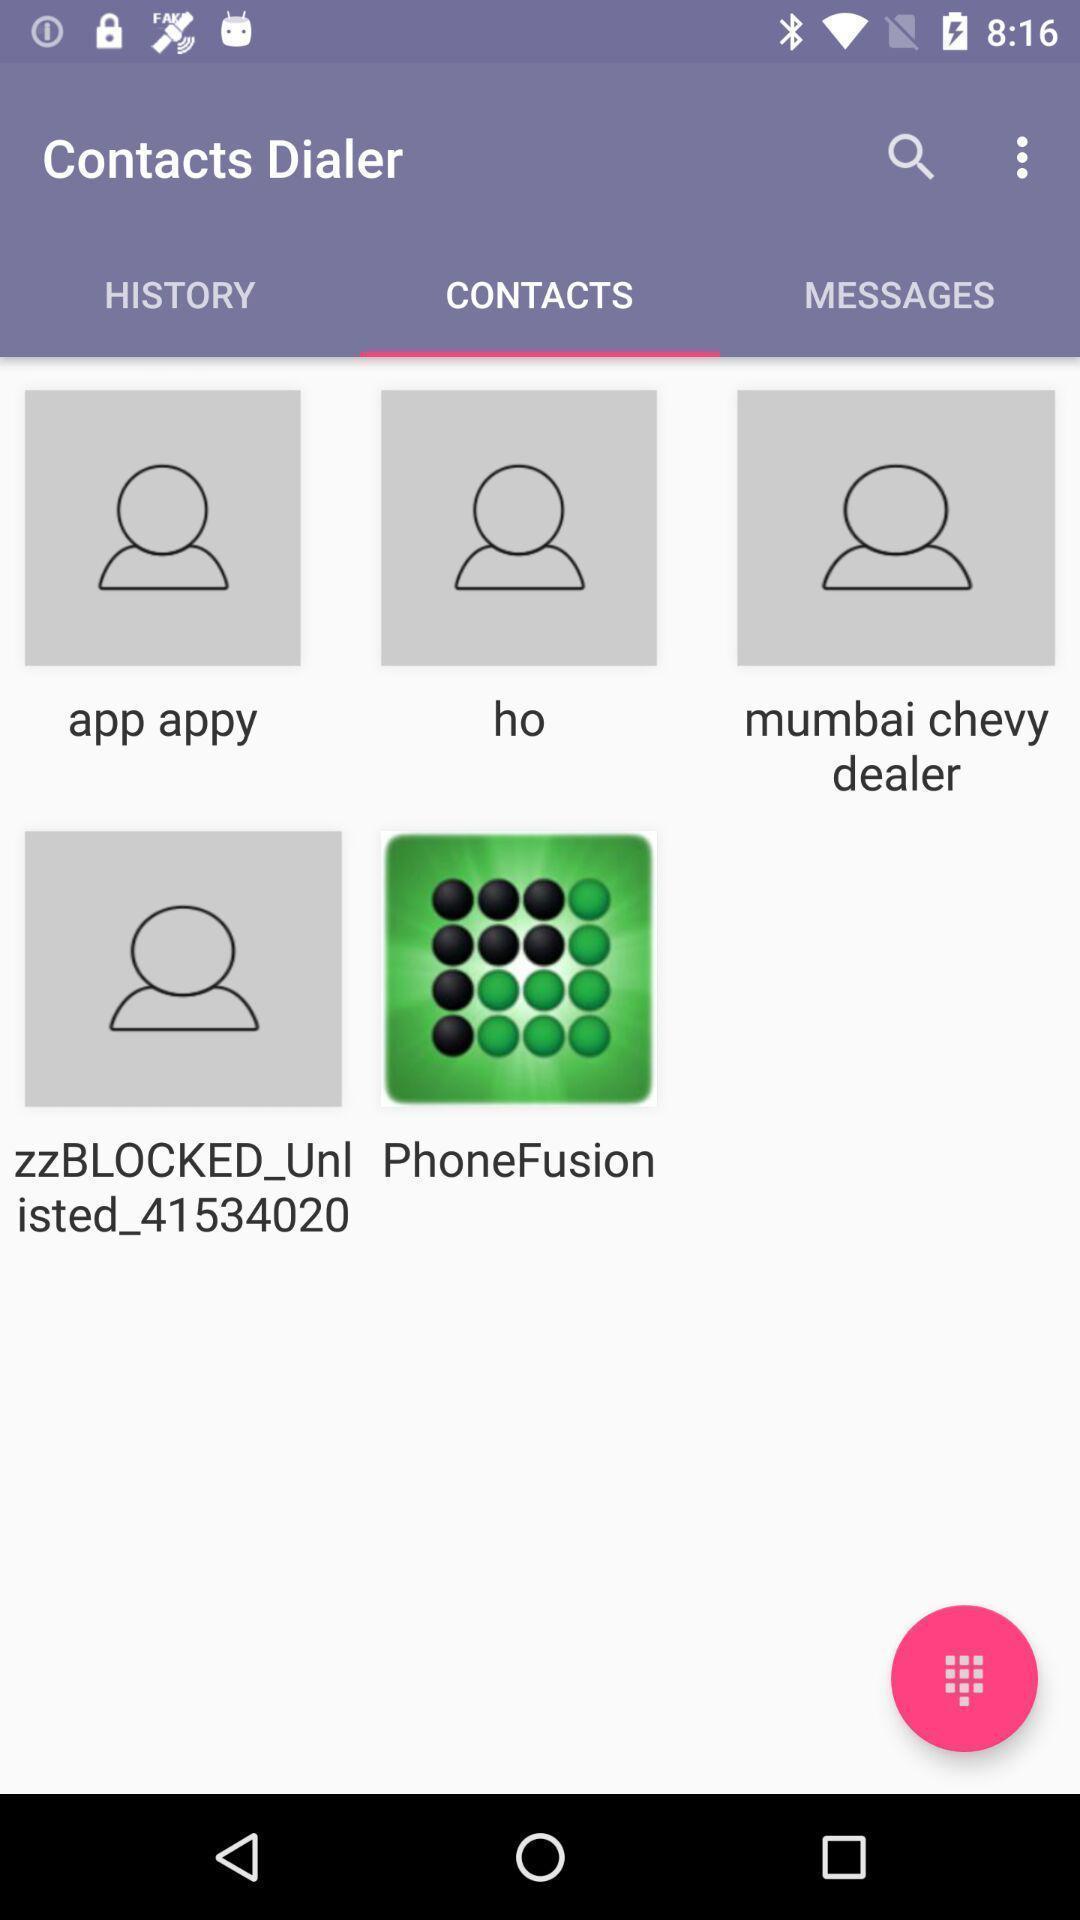Describe the key features of this screenshot. Screen displaying the contacts page. 